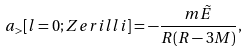Convert formula to latex. <formula><loc_0><loc_0><loc_500><loc_500>a _ { > } [ l = 0 ; Z e r i l l i ] = - \frac { m \tilde { E } } { R ( R - 3 M ) } ,</formula> 